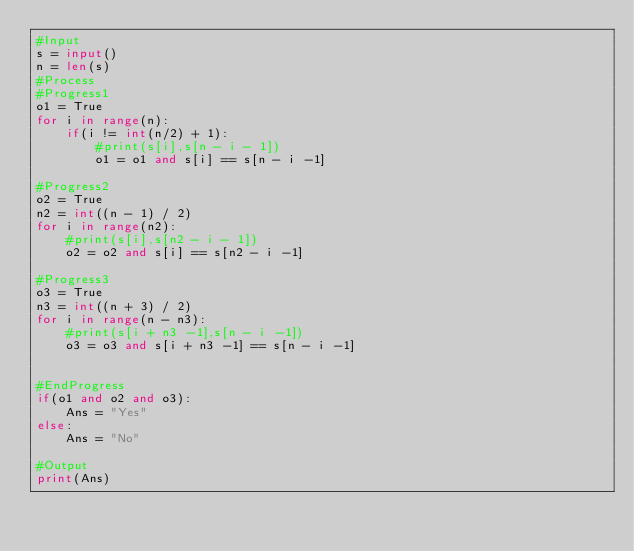Convert code to text. <code><loc_0><loc_0><loc_500><loc_500><_Python_>#Input
s = input()
n = len(s)
#Process
#Progress1
o1 = True
for i in range(n):
    if(i != int(n/2) + 1):
        #print(s[i],s[n - i - 1])
        o1 = o1 and s[i] == s[n - i -1]

#Progress2
o2 = True
n2 = int((n - 1) / 2)
for i in range(n2):
    #print(s[i],s[n2 - i - 1])
    o2 = o2 and s[i] == s[n2 - i -1]
    
#Progress3
o3 = True
n3 = int((n + 3) / 2)
for i in range(n - n3):
    #print(s[i + n3 -1],s[n - i -1])
    o3 = o3 and s[i + n3 -1] == s[n - i -1]


#EndProgress
if(o1 and o2 and o3): 
    Ans = "Yes"
else:
    Ans = "No"

#Output
print(Ans)</code> 